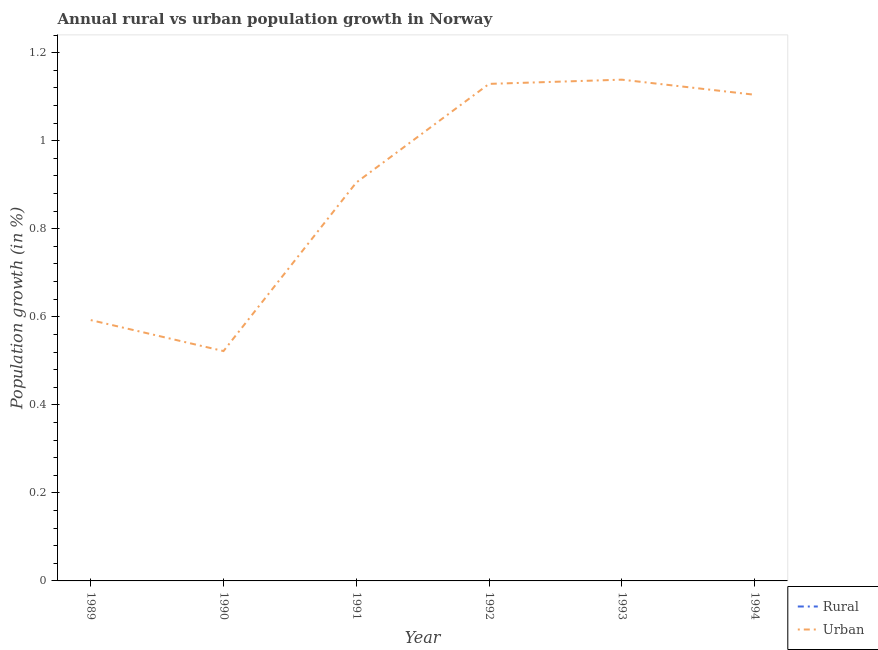How many different coloured lines are there?
Offer a very short reply. 1. Across all years, what is the maximum urban population growth?
Provide a short and direct response. 1.14. Across all years, what is the minimum rural population growth?
Provide a succinct answer. 0. What is the total urban population growth in the graph?
Your response must be concise. 5.39. What is the difference between the urban population growth in 1990 and that in 1994?
Your answer should be compact. -0.58. What is the difference between the rural population growth in 1991 and the urban population growth in 1990?
Offer a very short reply. -0.52. What is the average urban population growth per year?
Give a very brief answer. 0.9. What is the ratio of the urban population growth in 1992 to that in 1993?
Make the answer very short. 0.99. What is the difference between the highest and the second highest urban population growth?
Your answer should be compact. 0.01. What is the difference between the highest and the lowest urban population growth?
Your response must be concise. 0.62. Does the rural population growth monotonically increase over the years?
Keep it short and to the point. No. What is the difference between two consecutive major ticks on the Y-axis?
Offer a terse response. 0.2. Does the graph contain any zero values?
Ensure brevity in your answer.  Yes. Does the graph contain grids?
Your response must be concise. No. How many legend labels are there?
Your answer should be compact. 2. How are the legend labels stacked?
Offer a very short reply. Vertical. What is the title of the graph?
Make the answer very short. Annual rural vs urban population growth in Norway. Does "Passenger Transport Items" appear as one of the legend labels in the graph?
Provide a short and direct response. No. What is the label or title of the Y-axis?
Provide a short and direct response. Population growth (in %). What is the Population growth (in %) in Rural in 1989?
Your response must be concise. 0. What is the Population growth (in %) of Urban  in 1989?
Keep it short and to the point. 0.59. What is the Population growth (in %) of Urban  in 1990?
Provide a succinct answer. 0.52. What is the Population growth (in %) of Rural in 1991?
Keep it short and to the point. 0. What is the Population growth (in %) in Urban  in 1991?
Provide a succinct answer. 0.91. What is the Population growth (in %) of Urban  in 1992?
Your answer should be very brief. 1.13. What is the Population growth (in %) in Rural in 1993?
Provide a short and direct response. 0. What is the Population growth (in %) of Urban  in 1993?
Your answer should be very brief. 1.14. What is the Population growth (in %) of Rural in 1994?
Offer a very short reply. 0. What is the Population growth (in %) of Urban  in 1994?
Your answer should be very brief. 1.1. Across all years, what is the maximum Population growth (in %) in Urban ?
Make the answer very short. 1.14. Across all years, what is the minimum Population growth (in %) of Urban ?
Your answer should be compact. 0.52. What is the total Population growth (in %) of Rural in the graph?
Make the answer very short. 0. What is the total Population growth (in %) in Urban  in the graph?
Offer a terse response. 5.39. What is the difference between the Population growth (in %) of Urban  in 1989 and that in 1990?
Provide a short and direct response. 0.07. What is the difference between the Population growth (in %) in Urban  in 1989 and that in 1991?
Keep it short and to the point. -0.31. What is the difference between the Population growth (in %) of Urban  in 1989 and that in 1992?
Your answer should be very brief. -0.54. What is the difference between the Population growth (in %) in Urban  in 1989 and that in 1993?
Offer a terse response. -0.55. What is the difference between the Population growth (in %) in Urban  in 1989 and that in 1994?
Give a very brief answer. -0.51. What is the difference between the Population growth (in %) in Urban  in 1990 and that in 1991?
Ensure brevity in your answer.  -0.38. What is the difference between the Population growth (in %) of Urban  in 1990 and that in 1992?
Ensure brevity in your answer.  -0.61. What is the difference between the Population growth (in %) in Urban  in 1990 and that in 1993?
Your response must be concise. -0.62. What is the difference between the Population growth (in %) in Urban  in 1990 and that in 1994?
Ensure brevity in your answer.  -0.58. What is the difference between the Population growth (in %) of Urban  in 1991 and that in 1992?
Your answer should be compact. -0.22. What is the difference between the Population growth (in %) in Urban  in 1991 and that in 1993?
Keep it short and to the point. -0.23. What is the difference between the Population growth (in %) in Urban  in 1991 and that in 1994?
Offer a terse response. -0.2. What is the difference between the Population growth (in %) of Urban  in 1992 and that in 1993?
Keep it short and to the point. -0.01. What is the difference between the Population growth (in %) of Urban  in 1992 and that in 1994?
Keep it short and to the point. 0.02. What is the difference between the Population growth (in %) of Urban  in 1993 and that in 1994?
Give a very brief answer. 0.03. What is the average Population growth (in %) of Urban  per year?
Give a very brief answer. 0.9. What is the ratio of the Population growth (in %) of Urban  in 1989 to that in 1990?
Make the answer very short. 1.13. What is the ratio of the Population growth (in %) of Urban  in 1989 to that in 1991?
Make the answer very short. 0.65. What is the ratio of the Population growth (in %) in Urban  in 1989 to that in 1992?
Make the answer very short. 0.52. What is the ratio of the Population growth (in %) in Urban  in 1989 to that in 1993?
Keep it short and to the point. 0.52. What is the ratio of the Population growth (in %) of Urban  in 1989 to that in 1994?
Give a very brief answer. 0.54. What is the ratio of the Population growth (in %) of Urban  in 1990 to that in 1991?
Keep it short and to the point. 0.58. What is the ratio of the Population growth (in %) of Urban  in 1990 to that in 1992?
Ensure brevity in your answer.  0.46. What is the ratio of the Population growth (in %) of Urban  in 1990 to that in 1993?
Ensure brevity in your answer.  0.46. What is the ratio of the Population growth (in %) in Urban  in 1990 to that in 1994?
Your response must be concise. 0.47. What is the ratio of the Population growth (in %) of Urban  in 1991 to that in 1992?
Make the answer very short. 0.8. What is the ratio of the Population growth (in %) of Urban  in 1991 to that in 1993?
Provide a short and direct response. 0.79. What is the ratio of the Population growth (in %) in Urban  in 1991 to that in 1994?
Provide a succinct answer. 0.82. What is the ratio of the Population growth (in %) in Urban  in 1992 to that in 1994?
Offer a very short reply. 1.02. What is the ratio of the Population growth (in %) of Urban  in 1993 to that in 1994?
Provide a short and direct response. 1.03. What is the difference between the highest and the second highest Population growth (in %) of Urban ?
Offer a terse response. 0.01. What is the difference between the highest and the lowest Population growth (in %) of Urban ?
Your answer should be compact. 0.62. 